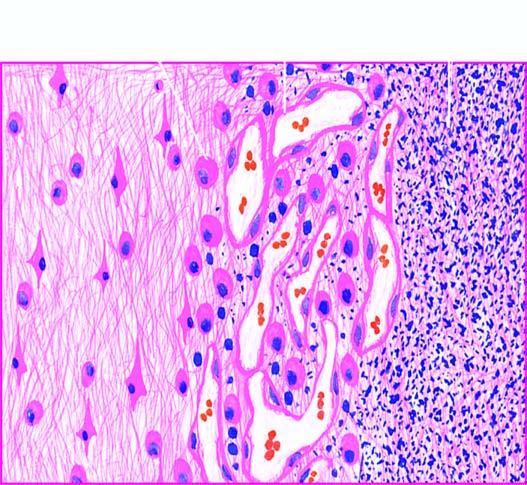what does the surrounding zone show?
Answer the question using a single word or phrase. Granulation tissue and gliosis 